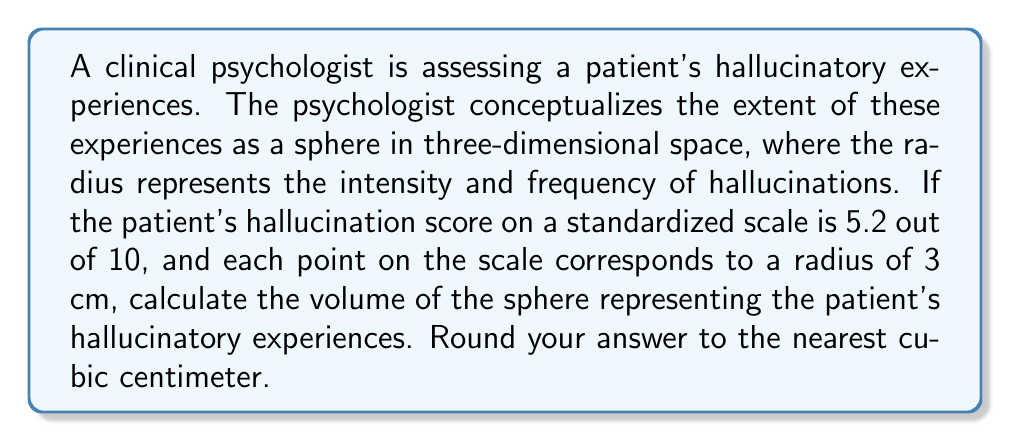Could you help me with this problem? To solve this problem, we need to follow these steps:

1. Determine the radius of the sphere:
   - The patient's score is 5.2 out of 10
   - Each point corresponds to a radius of 3 cm
   - Radius = $5.2 \times 3 = 15.6$ cm

2. Recall the formula for the volume of a sphere:
   $$ V = \frac{4}{3}\pi r^3 $$
   Where $V$ is the volume and $r$ is the radius.

3. Substitute the radius into the formula:
   $$ V = \frac{4}{3}\pi (15.6)^3 $$

4. Calculate:
   $$ V = \frac{4}{3}\pi \times 3796.416 $$
   $$ V = 4 \times 1265.472 \times \pi $$
   $$ V = 5061.888 \pi $$
   $$ V \approx 15,892.36 \text{ cm}^3 $$

5. Round to the nearest cubic centimeter:
   $$ V \approx 15,892 \text{ cm}^3 $$
Answer: The volume of the sphere representing the patient's hallucinatory experiences is approximately 15,892 cm³. 